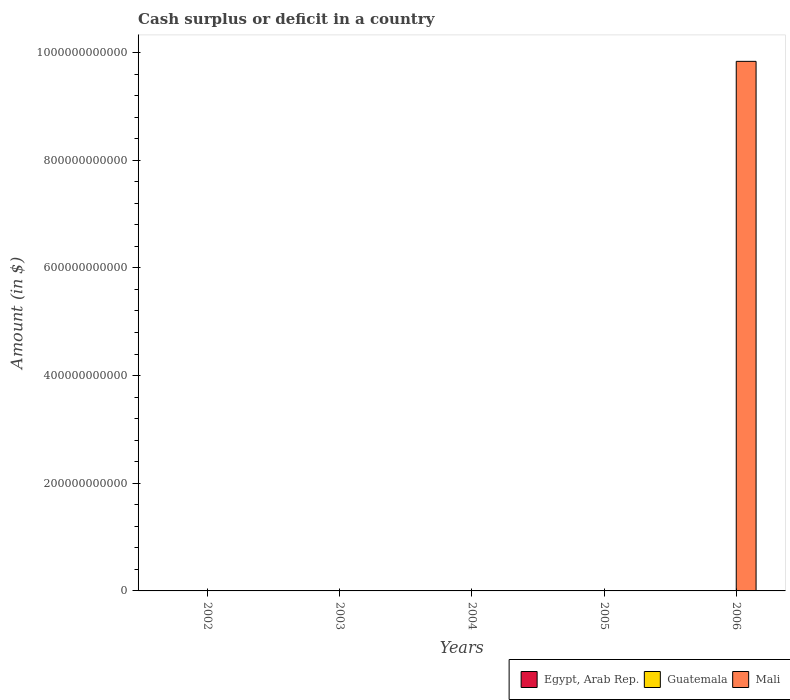How many different coloured bars are there?
Give a very brief answer. 1. Are the number of bars on each tick of the X-axis equal?
Offer a very short reply. No. How many bars are there on the 1st tick from the left?
Offer a very short reply. 0. How many bars are there on the 1st tick from the right?
Your answer should be compact. 1. In how many cases, is the number of bars for a given year not equal to the number of legend labels?
Offer a terse response. 5. Across all years, what is the maximum amount of cash surplus or deficit in Mali?
Your response must be concise. 9.83e+11. In which year was the amount of cash surplus or deficit in Mali maximum?
Your response must be concise. 2006. What is the total amount of cash surplus or deficit in Egypt, Arab Rep. in the graph?
Make the answer very short. 0. What is the average amount of cash surplus or deficit in Mali per year?
Provide a short and direct response. 1.97e+11. What is the difference between the highest and the lowest amount of cash surplus or deficit in Mali?
Your answer should be very brief. 9.83e+11. In how many years, is the amount of cash surplus or deficit in Egypt, Arab Rep. greater than the average amount of cash surplus or deficit in Egypt, Arab Rep. taken over all years?
Offer a terse response. 0. Is it the case that in every year, the sum of the amount of cash surplus or deficit in Mali and amount of cash surplus or deficit in Egypt, Arab Rep. is greater than the amount of cash surplus or deficit in Guatemala?
Your response must be concise. No. How many bars are there?
Your answer should be very brief. 1. What is the difference between two consecutive major ticks on the Y-axis?
Keep it short and to the point. 2.00e+11. Does the graph contain any zero values?
Keep it short and to the point. Yes. Does the graph contain grids?
Keep it short and to the point. No. How many legend labels are there?
Your response must be concise. 3. What is the title of the graph?
Ensure brevity in your answer.  Cash surplus or deficit in a country. What is the label or title of the Y-axis?
Your answer should be very brief. Amount (in $). What is the Amount (in $) of Guatemala in 2002?
Your response must be concise. 0. What is the Amount (in $) in Egypt, Arab Rep. in 2003?
Your response must be concise. 0. What is the Amount (in $) of Mali in 2003?
Your response must be concise. 0. What is the Amount (in $) in Egypt, Arab Rep. in 2004?
Offer a very short reply. 0. What is the Amount (in $) of Guatemala in 2004?
Offer a terse response. 0. What is the Amount (in $) in Mali in 2004?
Your response must be concise. 0. What is the Amount (in $) in Guatemala in 2006?
Your answer should be compact. 0. What is the Amount (in $) of Mali in 2006?
Give a very brief answer. 9.83e+11. Across all years, what is the maximum Amount (in $) in Mali?
Give a very brief answer. 9.83e+11. Across all years, what is the minimum Amount (in $) in Mali?
Offer a very short reply. 0. What is the total Amount (in $) in Egypt, Arab Rep. in the graph?
Your response must be concise. 0. What is the total Amount (in $) in Mali in the graph?
Provide a short and direct response. 9.83e+11. What is the average Amount (in $) in Egypt, Arab Rep. per year?
Give a very brief answer. 0. What is the average Amount (in $) of Mali per year?
Keep it short and to the point. 1.97e+11. What is the difference between the highest and the lowest Amount (in $) of Mali?
Offer a terse response. 9.83e+11. 